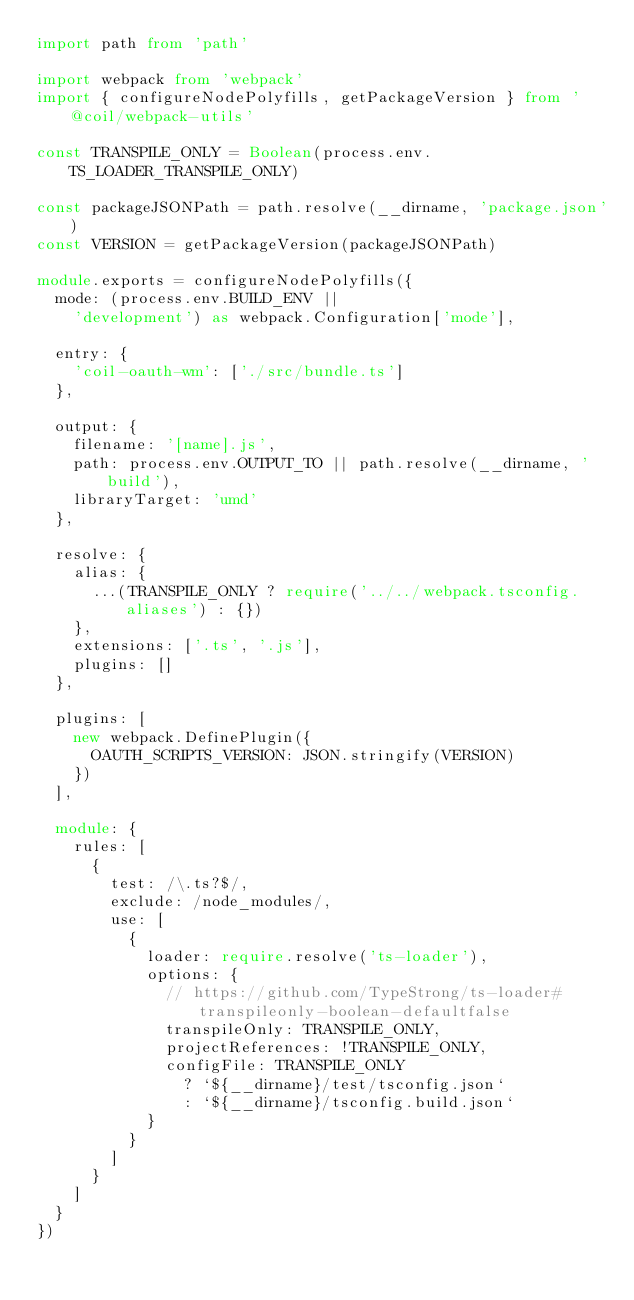Convert code to text. <code><loc_0><loc_0><loc_500><loc_500><_TypeScript_>import path from 'path'

import webpack from 'webpack'
import { configureNodePolyfills, getPackageVersion } from '@coil/webpack-utils'

const TRANSPILE_ONLY = Boolean(process.env.TS_LOADER_TRANSPILE_ONLY)

const packageJSONPath = path.resolve(__dirname, 'package.json')
const VERSION = getPackageVersion(packageJSONPath)

module.exports = configureNodePolyfills({
  mode: (process.env.BUILD_ENV ||
    'development') as webpack.Configuration['mode'],

  entry: {
    'coil-oauth-wm': ['./src/bundle.ts']
  },

  output: {
    filename: '[name].js',
    path: process.env.OUTPUT_TO || path.resolve(__dirname, 'build'),
    libraryTarget: 'umd'
  },

  resolve: {
    alias: {
      ...(TRANSPILE_ONLY ? require('../../webpack.tsconfig.aliases') : {})
    },
    extensions: ['.ts', '.js'],
    plugins: []
  },

  plugins: [
    new webpack.DefinePlugin({
      OAUTH_SCRIPTS_VERSION: JSON.stringify(VERSION)
    })
  ],

  module: {
    rules: [
      {
        test: /\.ts?$/,
        exclude: /node_modules/,
        use: [
          {
            loader: require.resolve('ts-loader'),
            options: {
              // https://github.com/TypeStrong/ts-loader#transpileonly-boolean-defaultfalse
              transpileOnly: TRANSPILE_ONLY,
              projectReferences: !TRANSPILE_ONLY,
              configFile: TRANSPILE_ONLY
                ? `${__dirname}/test/tsconfig.json`
                : `${__dirname}/tsconfig.build.json`
            }
          }
        ]
      }
    ]
  }
})
</code> 